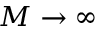<formula> <loc_0><loc_0><loc_500><loc_500>M \to \infty</formula> 